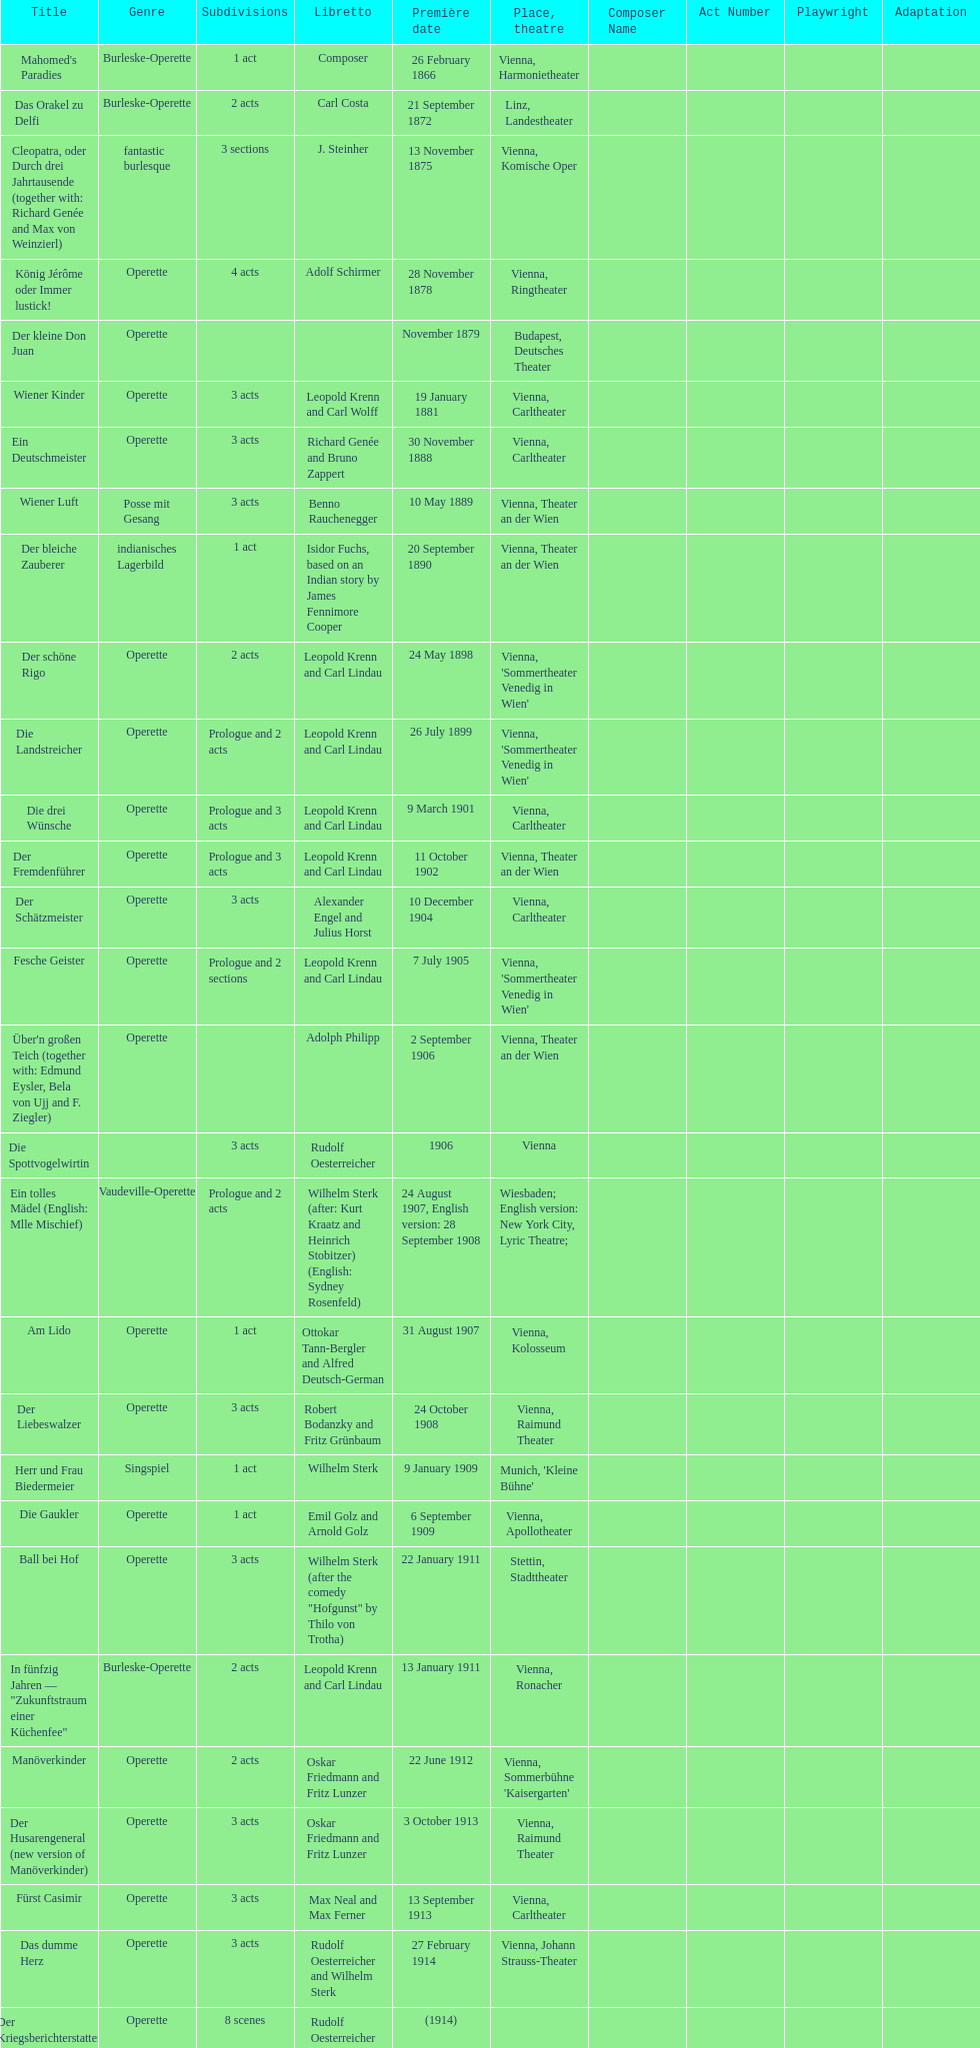How many of his operettas were 3 acts? 13. 